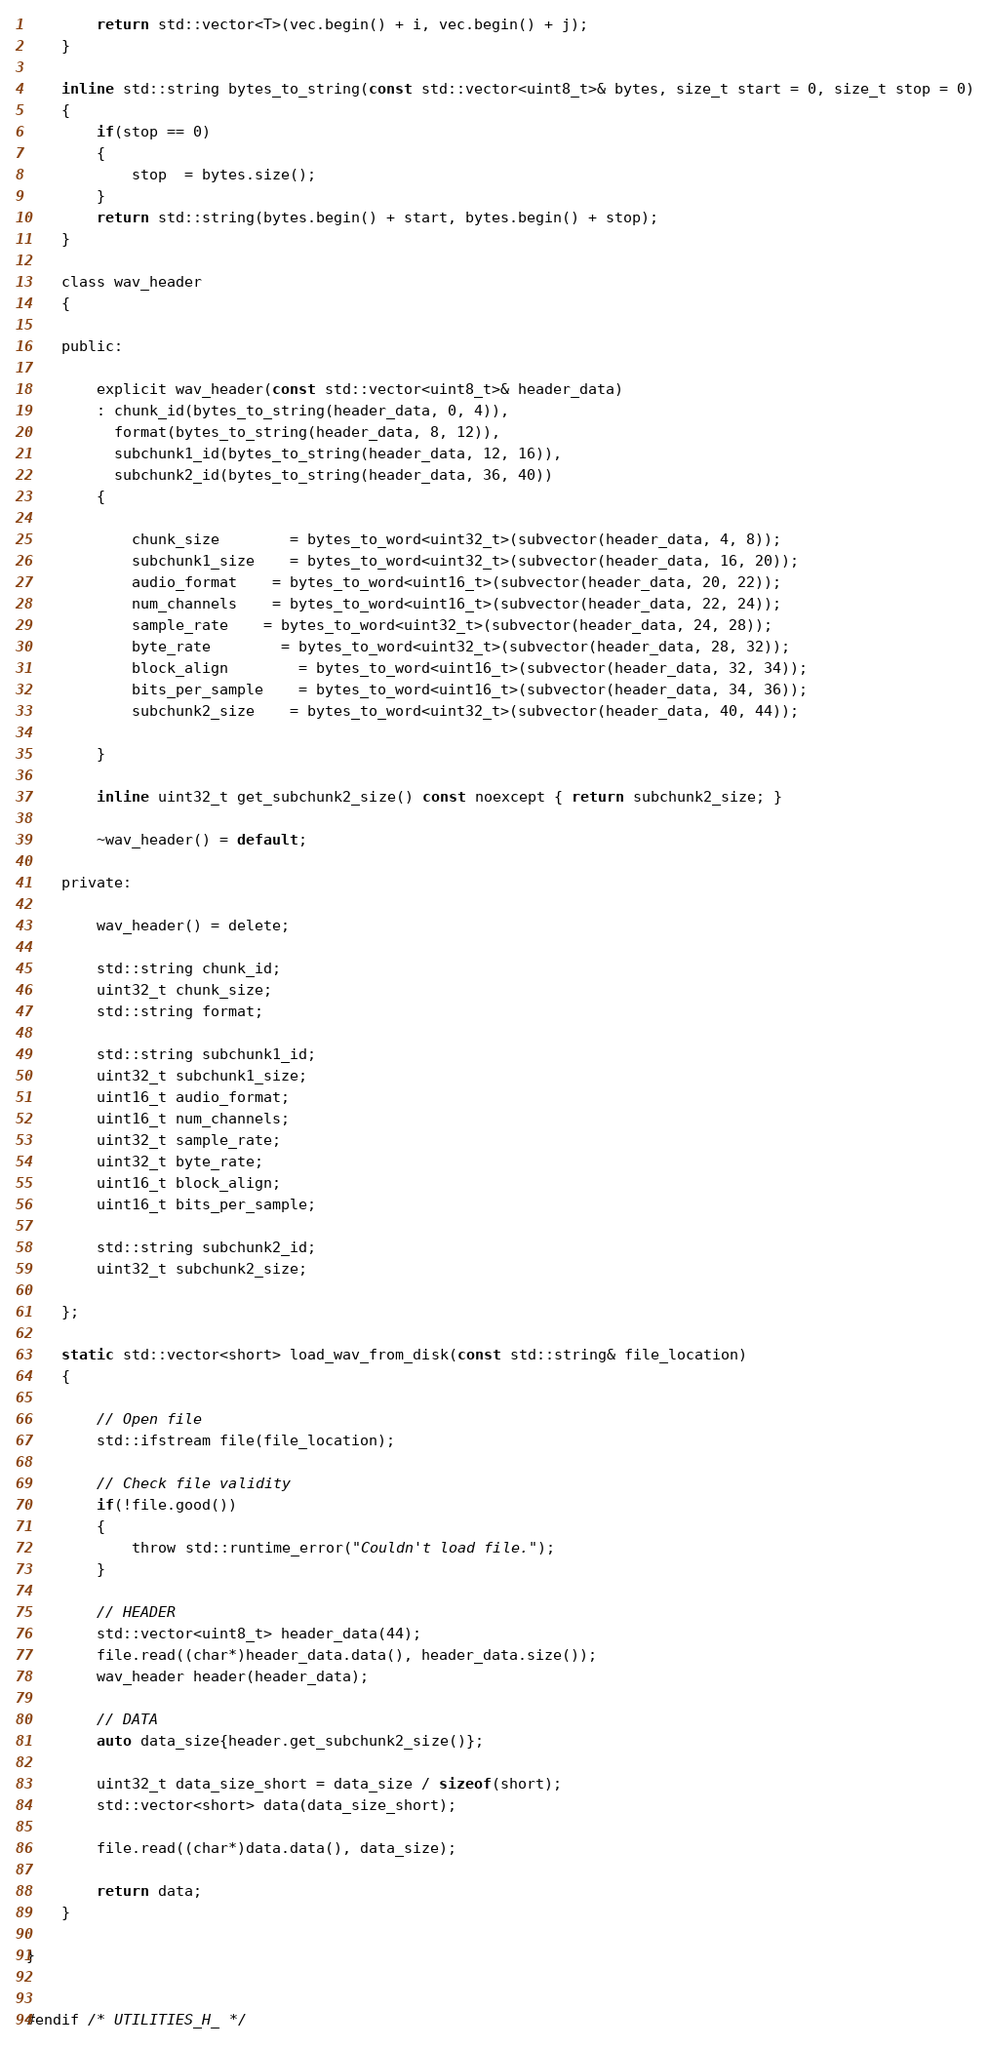<code> <loc_0><loc_0><loc_500><loc_500><_C_>		return std::vector<T>(vec.begin() + i, vec.begin() + j);
	}

	inline std::string bytes_to_string(const std::vector<uint8_t>& bytes, size_t start = 0, size_t stop = 0)
	{
		if(stop == 0)
		{
			stop  = bytes.size();
		}
		return std::string(bytes.begin() + start, bytes.begin() + stop);
	}

	class wav_header
	{

	public:

		explicit wav_header(const std::vector<uint8_t>& header_data)
		: chunk_id(bytes_to_string(header_data, 0, 4)),
		  format(bytes_to_string(header_data, 8, 12)),
		  subchunk1_id(bytes_to_string(header_data, 12, 16)),
		  subchunk2_id(bytes_to_string(header_data, 36, 40))
		{

			chunk_size 		= bytes_to_word<uint32_t>(subvector(header_data, 4, 8));
			subchunk1_size 	= bytes_to_word<uint32_t>(subvector(header_data, 16, 20));
			audio_format 	= bytes_to_word<uint16_t>(subvector(header_data, 20, 22));
			num_channels 	= bytes_to_word<uint16_t>(subvector(header_data, 22, 24));
			sample_rate 	= bytes_to_word<uint32_t>(subvector(header_data, 24, 28));
			byte_rate		= bytes_to_word<uint32_t>(subvector(header_data, 28, 32));
			block_align		= bytes_to_word<uint16_t>(subvector(header_data, 32, 34));
			bits_per_sample	= bytes_to_word<uint16_t>(subvector(header_data, 34, 36));
			subchunk2_size 	= bytes_to_word<uint32_t>(subvector(header_data, 40, 44));

		}

		inline uint32_t get_subchunk2_size() const noexcept { return subchunk2_size; }

		~wav_header() = default;

	private:

		wav_header() = delete;

		std::string chunk_id;
		uint32_t chunk_size;
		std::string format;

		std::string subchunk1_id;
		uint32_t subchunk1_size;
		uint16_t audio_format;
		uint16_t num_channels;
		uint32_t sample_rate;
		uint32_t byte_rate;
		uint16_t block_align;
		uint16_t bits_per_sample;

		std::string subchunk2_id;
		uint32_t subchunk2_size;

	};

	static std::vector<short> load_wav_from_disk(const std::string& file_location)
	{

		// Open file
		std::ifstream file(file_location);

		// Check file validity
		if(!file.good())
		{
			throw std::runtime_error("Couldn't load file.");
		}

		// HEADER
		std::vector<uint8_t> header_data(44);
		file.read((char*)header_data.data(), header_data.size());
		wav_header header(header_data);

		// DATA
		auto data_size{header.get_subchunk2_size()};

		uint32_t data_size_short = data_size / sizeof(short);
		std::vector<short> data(data_size_short);

		file.read((char*)data.data(), data_size);

		return data;
	}

}


#endif /* UTILITIES_H_ */
</code> 